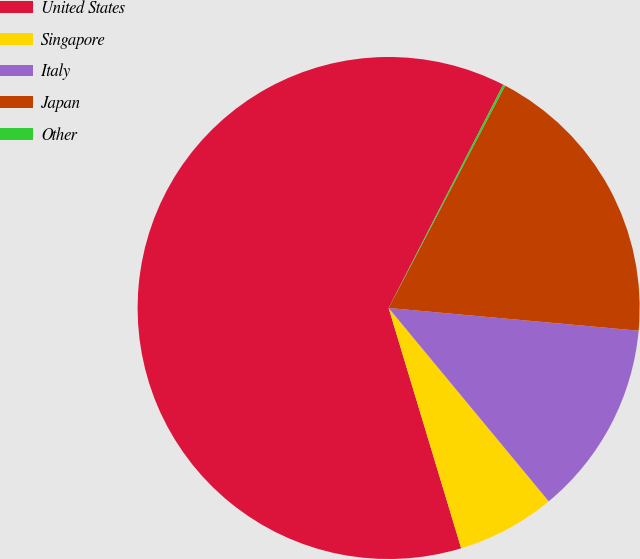Convert chart. <chart><loc_0><loc_0><loc_500><loc_500><pie_chart><fcel>United States<fcel>Singapore<fcel>Italy<fcel>Japan<fcel>Other<nl><fcel>62.21%<fcel>6.34%<fcel>12.55%<fcel>18.76%<fcel>0.14%<nl></chart> 